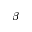Convert formula to latex. <formula><loc_0><loc_0><loc_500><loc_500>{ \beta }</formula> 